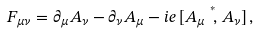Convert formula to latex. <formula><loc_0><loc_0><loc_500><loc_500>F _ { \mu \nu } = \partial _ { \mu } A _ { \nu } - \partial _ { \nu } A _ { \mu } - i e \, [ A _ { \mu } \stackrel { ^ { * } } { \, , } A _ { \nu } ] \, ,</formula> 